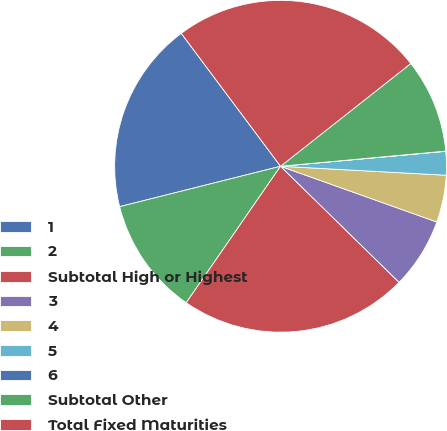Convert chart to OTSL. <chart><loc_0><loc_0><loc_500><loc_500><pie_chart><fcel>1<fcel>2<fcel>Subtotal High or Highest<fcel>3<fcel>4<fcel>5<fcel>6<fcel>Subtotal Other<fcel>Total Fixed Maturities<nl><fcel>18.7%<fcel>11.46%<fcel>22.29%<fcel>6.88%<fcel>4.59%<fcel>2.3%<fcel>0.02%<fcel>9.17%<fcel>24.58%<nl></chart> 